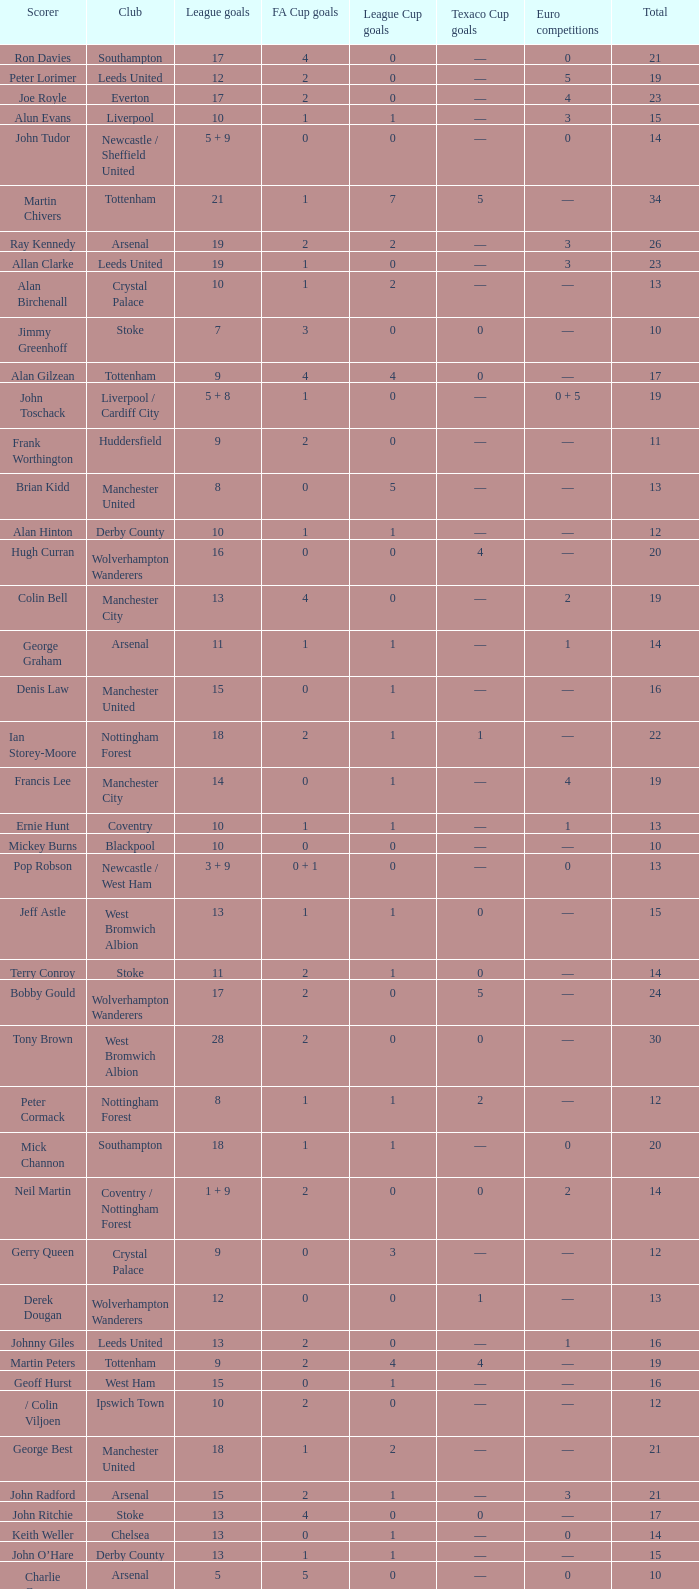What is the average Total, when FA Cup Goals is 1, when League Goals is 10, and when Club is Crystal Palace? 13.0. 